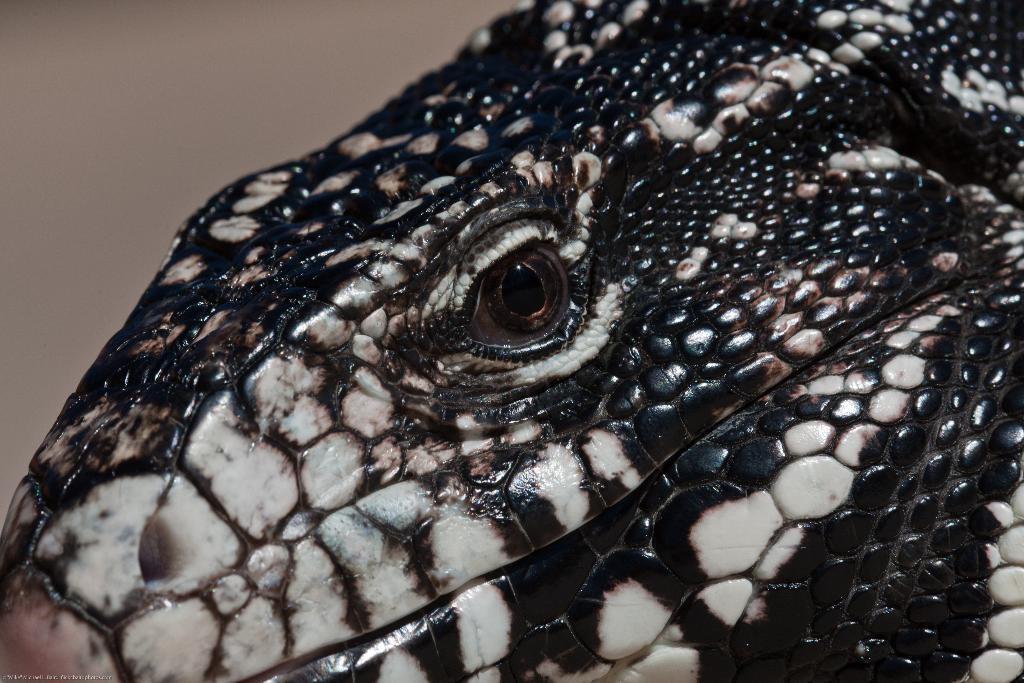Describe this image in one or two sentences. As we can see in the image there is a black color animal and in the background there is a wall. 